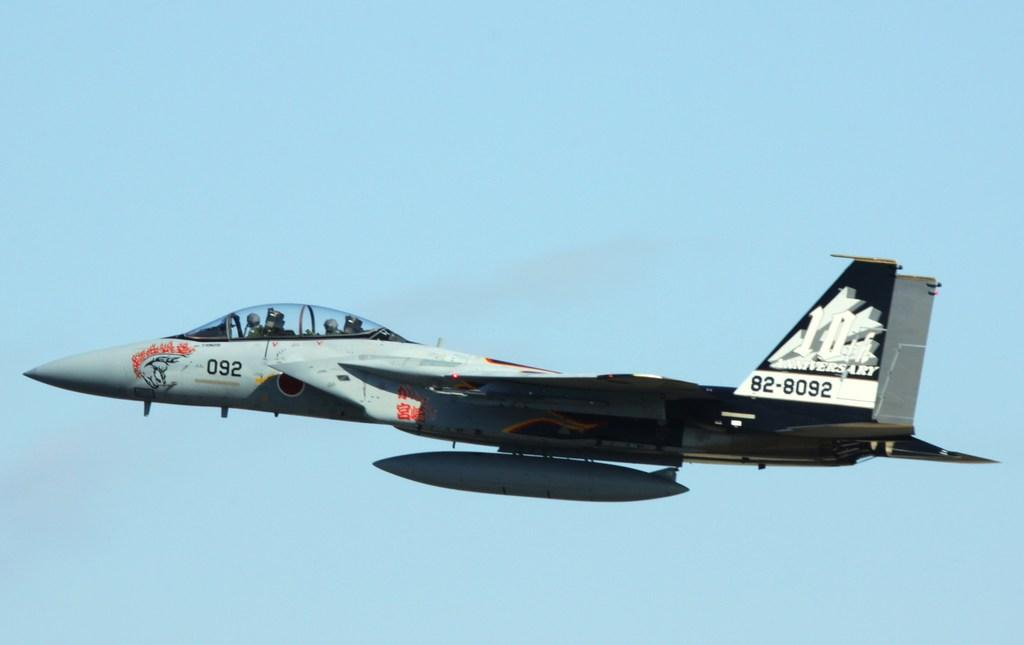Provide a one-sentence caption for the provided image. A fighter jet is flying through the sky with the numbers 82-8092 written on its tail. 